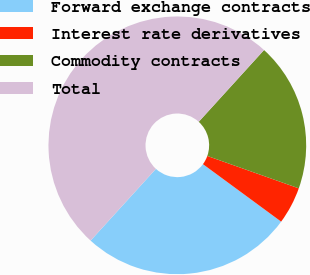<chart> <loc_0><loc_0><loc_500><loc_500><pie_chart><fcel>Forward exchange contracts<fcel>Interest rate derivatives<fcel>Commodity contracts<fcel>Total<nl><fcel>26.67%<fcel>4.67%<fcel>18.67%<fcel>50.0%<nl></chart> 